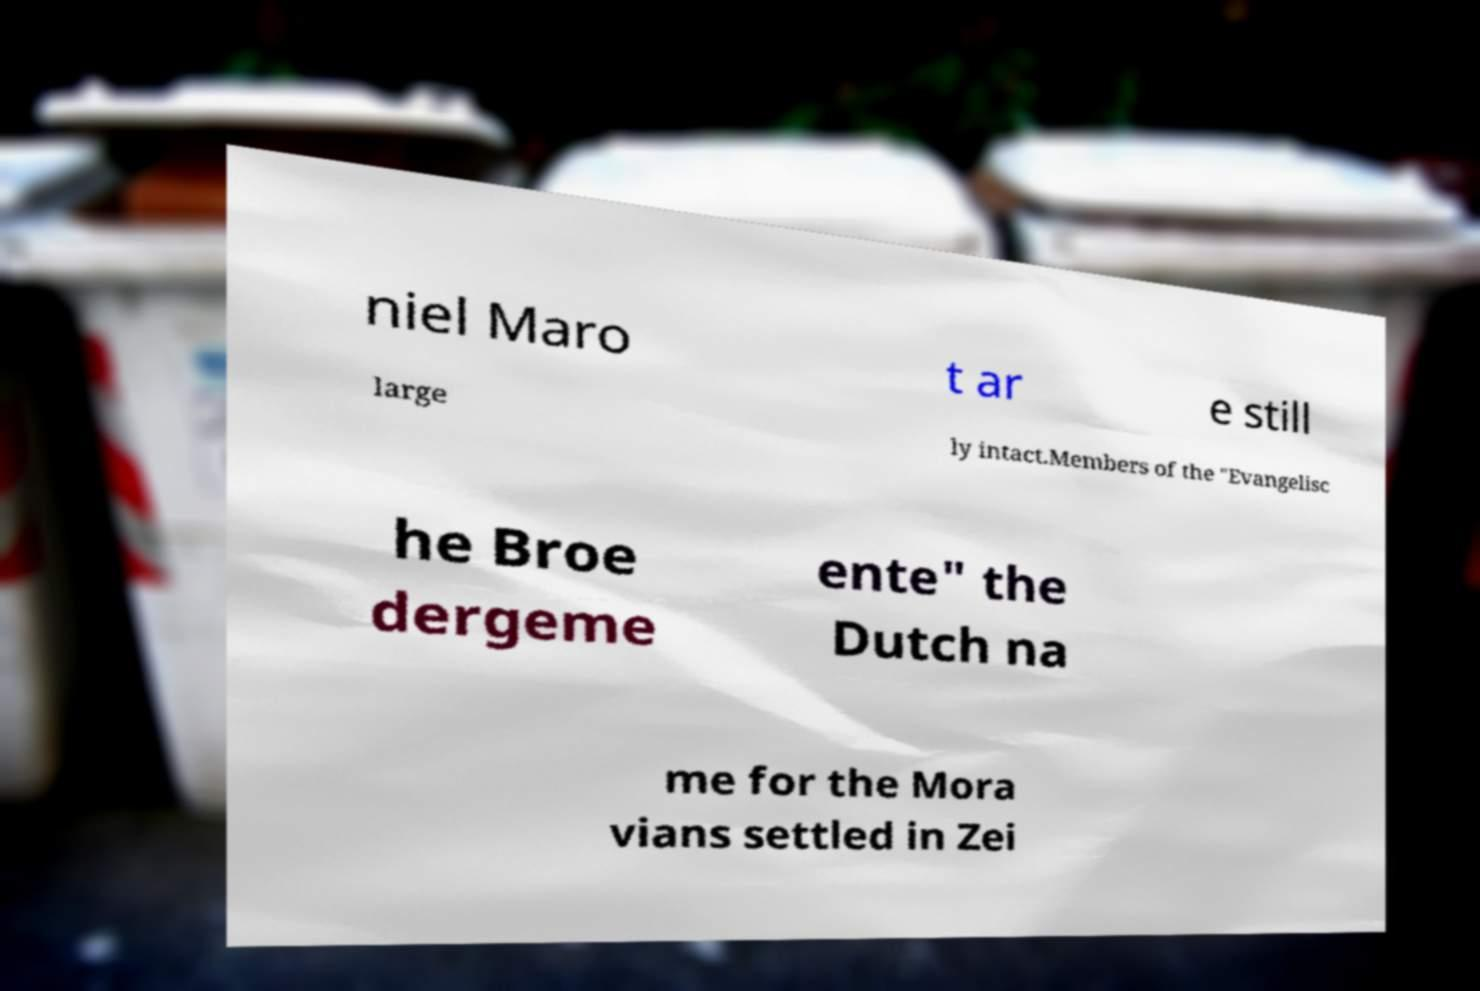What messages or text are displayed in this image? I need them in a readable, typed format. niel Maro t ar e still large ly intact.Members of the "Evangelisc he Broe dergeme ente" the Dutch na me for the Mora vians settled in Zei 